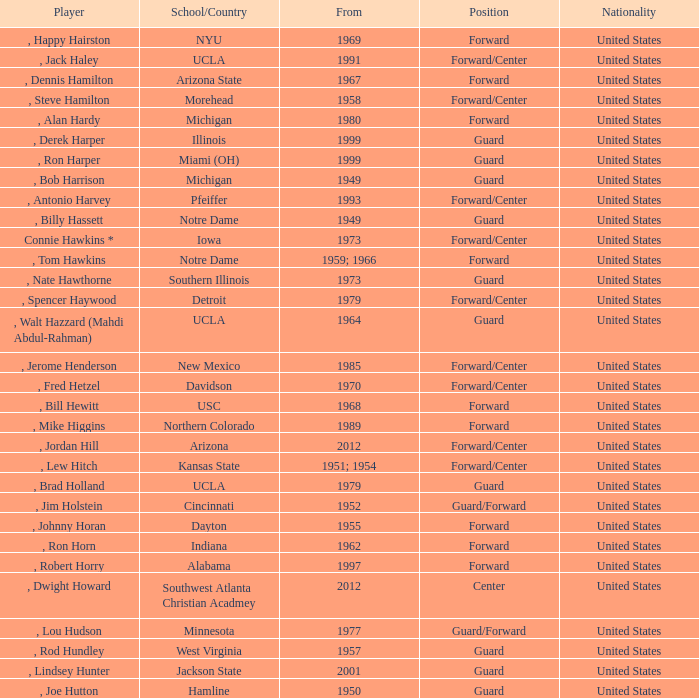Which school has the player that started in 1958? Morehead. Could you help me parse every detail presented in this table? {'header': ['Player', 'School/Country', 'From', 'Position', 'Nationality'], 'rows': [[', Happy Hairston', 'NYU', '1969', 'Forward', 'United States'], [', Jack Haley', 'UCLA', '1991', 'Forward/Center', 'United States'], [', Dennis Hamilton', 'Arizona State', '1967', 'Forward', 'United States'], [', Steve Hamilton', 'Morehead', '1958', 'Forward/Center', 'United States'], [', Alan Hardy', 'Michigan', '1980', 'Forward', 'United States'], [', Derek Harper', 'Illinois', '1999', 'Guard', 'United States'], [', Ron Harper', 'Miami (OH)', '1999', 'Guard', 'United States'], [', Bob Harrison', 'Michigan', '1949', 'Guard', 'United States'], [', Antonio Harvey', 'Pfeiffer', '1993', 'Forward/Center', 'United States'], [', Billy Hassett', 'Notre Dame', '1949', 'Guard', 'United States'], ['Connie Hawkins *', 'Iowa', '1973', 'Forward/Center', 'United States'], [', Tom Hawkins', 'Notre Dame', '1959; 1966', 'Forward', 'United States'], [', Nate Hawthorne', 'Southern Illinois', '1973', 'Guard', 'United States'], [', Spencer Haywood', 'Detroit', '1979', 'Forward/Center', 'United States'], [', Walt Hazzard (Mahdi Abdul-Rahman)', 'UCLA', '1964', 'Guard', 'United States'], [', Jerome Henderson', 'New Mexico', '1985', 'Forward/Center', 'United States'], [', Fred Hetzel', 'Davidson', '1970', 'Forward/Center', 'United States'], [', Bill Hewitt', 'USC', '1968', 'Forward', 'United States'], [', Mike Higgins', 'Northern Colorado', '1989', 'Forward', 'United States'], [', Jordan Hill', 'Arizona', '2012', 'Forward/Center', 'United States'], [', Lew Hitch', 'Kansas State', '1951; 1954', 'Forward/Center', 'United States'], [', Brad Holland', 'UCLA', '1979', 'Guard', 'United States'], [', Jim Holstein', 'Cincinnati', '1952', 'Guard/Forward', 'United States'], [', Johnny Horan', 'Dayton', '1955', 'Forward', 'United States'], [', Ron Horn', 'Indiana', '1962', 'Forward', 'United States'], [', Robert Horry', 'Alabama', '1997', 'Forward', 'United States'], [', Dwight Howard', 'Southwest Atlanta Christian Acadmey', '2012', 'Center', 'United States'], [', Lou Hudson', 'Minnesota', '1977', 'Guard/Forward', 'United States'], [', Rod Hundley', 'West Virginia', '1957', 'Guard', 'United States'], [', Lindsey Hunter', 'Jackson State', '2001', 'Guard', 'United States'], [', Joe Hutton', 'Hamline', '1950', 'Guard', 'United States']]} 